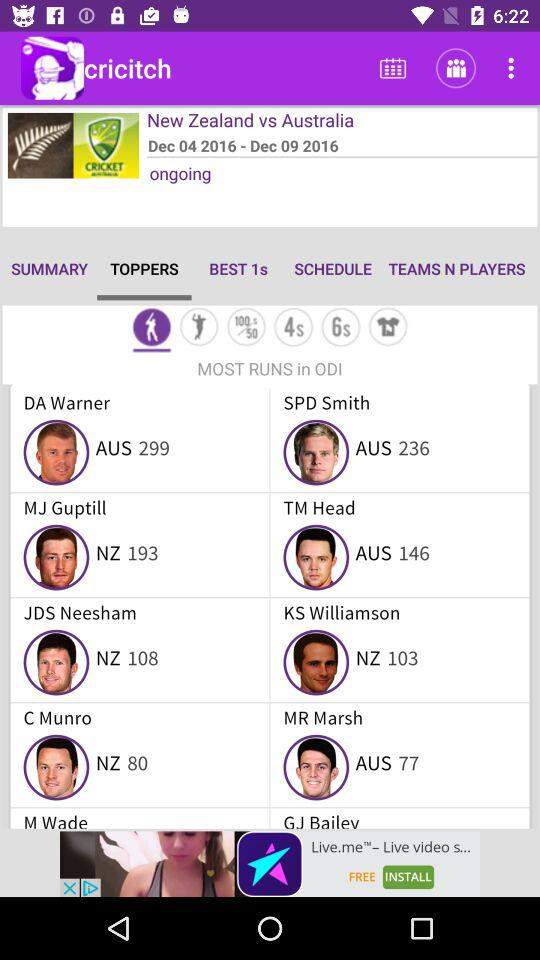How many runs did TM Head score? TM Head scored 146 runs. 